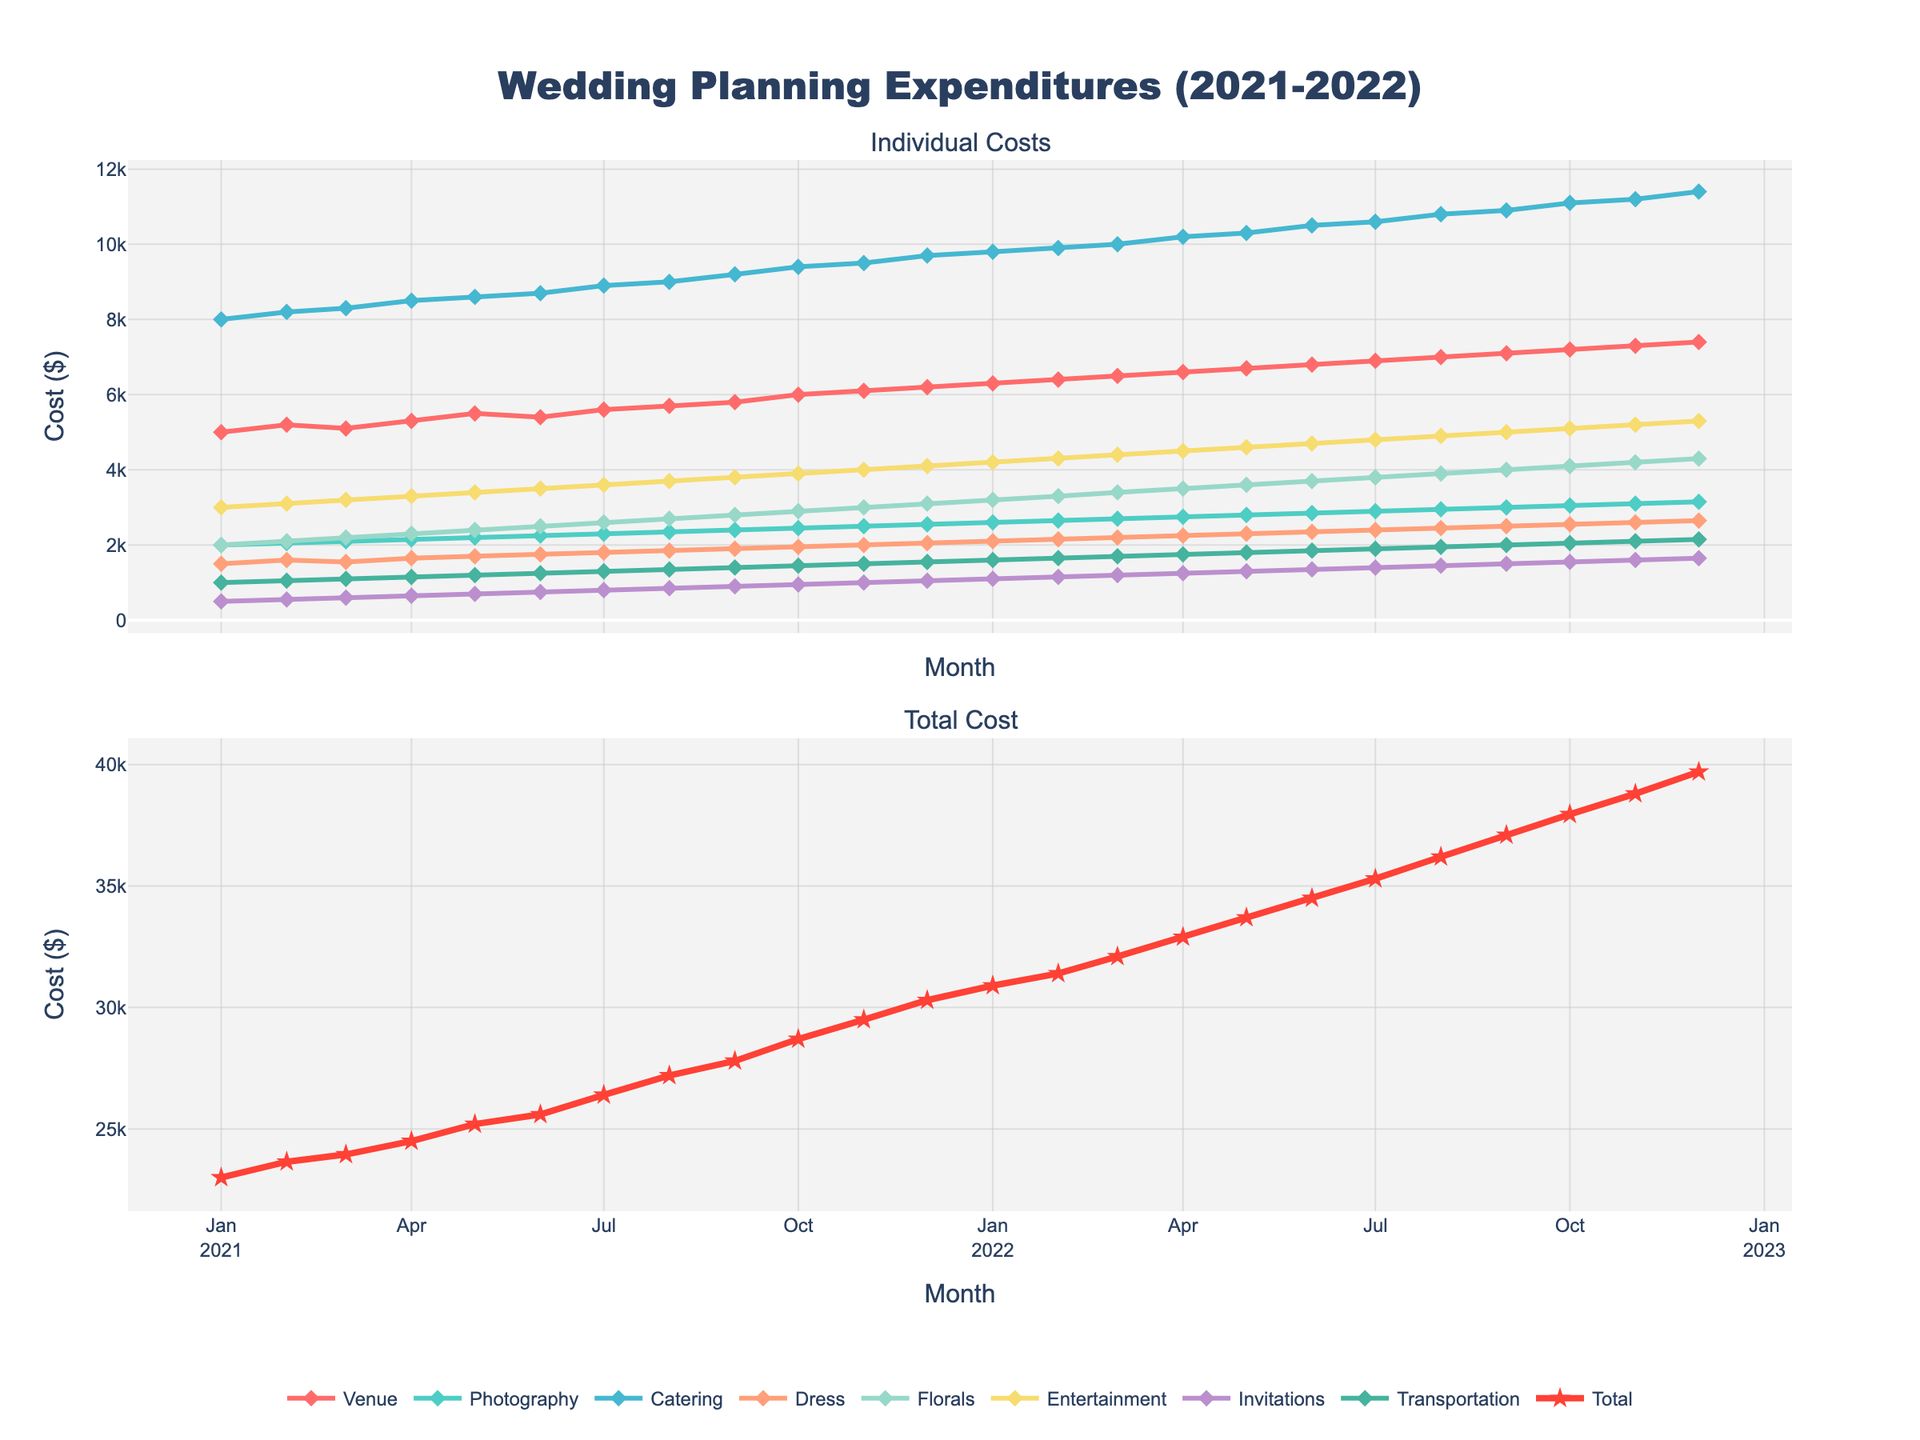what is the title of the figure? The title of the figure is displayed at the top center, and it reads "Wedding Planning Expenditures (2021-2022)."
Answer: Wedding Planning Expenditures (2021-2022) Which category had the highest expenditures in December 2022? In December 2022, you can look at the corresponding data point for each category in the upper subplot. Catering has the highest value at $11,400.
Answer: Catering How did the total monthly expenditures change from January 2021 to December 2022? To understand the change in total monthly expenditures, compare the total expenditure points at January 2021 and December 2022 in the lower subplot. The expenditure increased from $23,000 to $39,700.
Answer: Increased What month in 2021 had the lowest entertainment costs? In the first subplot, find the lowest point for the Entertainment line in 2021. January 2021 had the lowest Entertainment cost at $3,000.
Answer: January 2021 Which category showed the most significant increase in cost between January 2021 and December 2022? Look at all categories by comparing the values at January 2021 and December 2022. Catering increased the most significantly from $8,000 to $11,400.
Answer: Catering In what month did the total cost first exceed $30,000? In the lower subplot, locate the first data point where the total cost exceeds $30,000. It happened in December 2021.
Answer: December 2021 Compare the trends of Venue and Transportation costs. What do you observe? Both trends increase over time, but the Venue costs start higher and increase more steeply than Transportation costs, which rise more gradually. The gap between Venue and Transportation costs widens over time.
Answer: Venue increases more steeply How much did the florals cost increase from January 2021 to December 2022? Calculate the difference between the Floral costs in January 2021 ($2,000) and December 2022 ($4,300). The increase is $2,300.
Answer: $2,300 